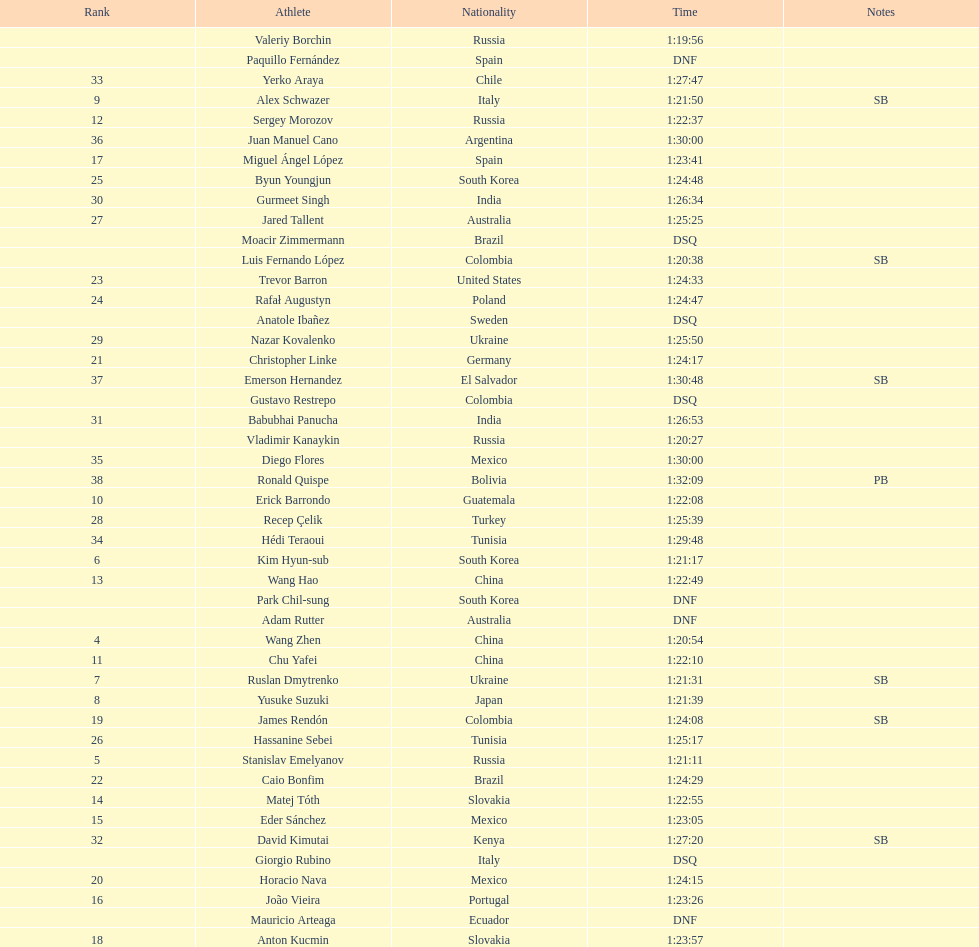Which competitor was ranked first? Valeriy Borchin. I'm looking to parse the entire table for insights. Could you assist me with that? {'header': ['Rank', 'Athlete', 'Nationality', 'Time', 'Notes'], 'rows': [['', 'Valeriy Borchin', 'Russia', '1:19:56', ''], ['', 'Paquillo Fernández', 'Spain', 'DNF', ''], ['33', 'Yerko Araya', 'Chile', '1:27:47', ''], ['9', 'Alex Schwazer', 'Italy', '1:21:50', 'SB'], ['12', 'Sergey Morozov', 'Russia', '1:22:37', ''], ['36', 'Juan Manuel Cano', 'Argentina', '1:30:00', ''], ['17', 'Miguel Ángel López', 'Spain', '1:23:41', ''], ['25', 'Byun Youngjun', 'South Korea', '1:24:48', ''], ['30', 'Gurmeet Singh', 'India', '1:26:34', ''], ['27', 'Jared Tallent', 'Australia', '1:25:25', ''], ['', 'Moacir Zimmermann', 'Brazil', 'DSQ', ''], ['', 'Luis Fernando López', 'Colombia', '1:20:38', 'SB'], ['23', 'Trevor Barron', 'United States', '1:24:33', ''], ['24', 'Rafał Augustyn', 'Poland', '1:24:47', ''], ['', 'Anatole Ibañez', 'Sweden', 'DSQ', ''], ['29', 'Nazar Kovalenko', 'Ukraine', '1:25:50', ''], ['21', 'Christopher Linke', 'Germany', '1:24:17', ''], ['37', 'Emerson Hernandez', 'El Salvador', '1:30:48', 'SB'], ['', 'Gustavo Restrepo', 'Colombia', 'DSQ', ''], ['31', 'Babubhai Panucha', 'India', '1:26:53', ''], ['', 'Vladimir Kanaykin', 'Russia', '1:20:27', ''], ['35', 'Diego Flores', 'Mexico', '1:30:00', ''], ['38', 'Ronald Quispe', 'Bolivia', '1:32:09', 'PB'], ['10', 'Erick Barrondo', 'Guatemala', '1:22:08', ''], ['28', 'Recep Çelik', 'Turkey', '1:25:39', ''], ['34', 'Hédi Teraoui', 'Tunisia', '1:29:48', ''], ['6', 'Kim Hyun-sub', 'South Korea', '1:21:17', ''], ['13', 'Wang Hao', 'China', '1:22:49', ''], ['', 'Park Chil-sung', 'South Korea', 'DNF', ''], ['', 'Adam Rutter', 'Australia', 'DNF', ''], ['4', 'Wang Zhen', 'China', '1:20:54', ''], ['11', 'Chu Yafei', 'China', '1:22:10', ''], ['7', 'Ruslan Dmytrenko', 'Ukraine', '1:21:31', 'SB'], ['8', 'Yusuke Suzuki', 'Japan', '1:21:39', ''], ['19', 'James Rendón', 'Colombia', '1:24:08', 'SB'], ['26', 'Hassanine Sebei', 'Tunisia', '1:25:17', ''], ['5', 'Stanislav Emelyanov', 'Russia', '1:21:11', ''], ['22', 'Caio Bonfim', 'Brazil', '1:24:29', ''], ['14', 'Matej Tóth', 'Slovakia', '1:22:55', ''], ['15', 'Eder Sánchez', 'Mexico', '1:23:05', ''], ['32', 'David Kimutai', 'Kenya', '1:27:20', 'SB'], ['', 'Giorgio Rubino', 'Italy', 'DSQ', ''], ['20', 'Horacio Nava', 'Mexico', '1:24:15', ''], ['16', 'João Vieira', 'Portugal', '1:23:26', ''], ['', 'Mauricio Arteaga', 'Ecuador', 'DNF', ''], ['18', 'Anton Kucmin', 'Slovakia', '1:23:57', '']]} 